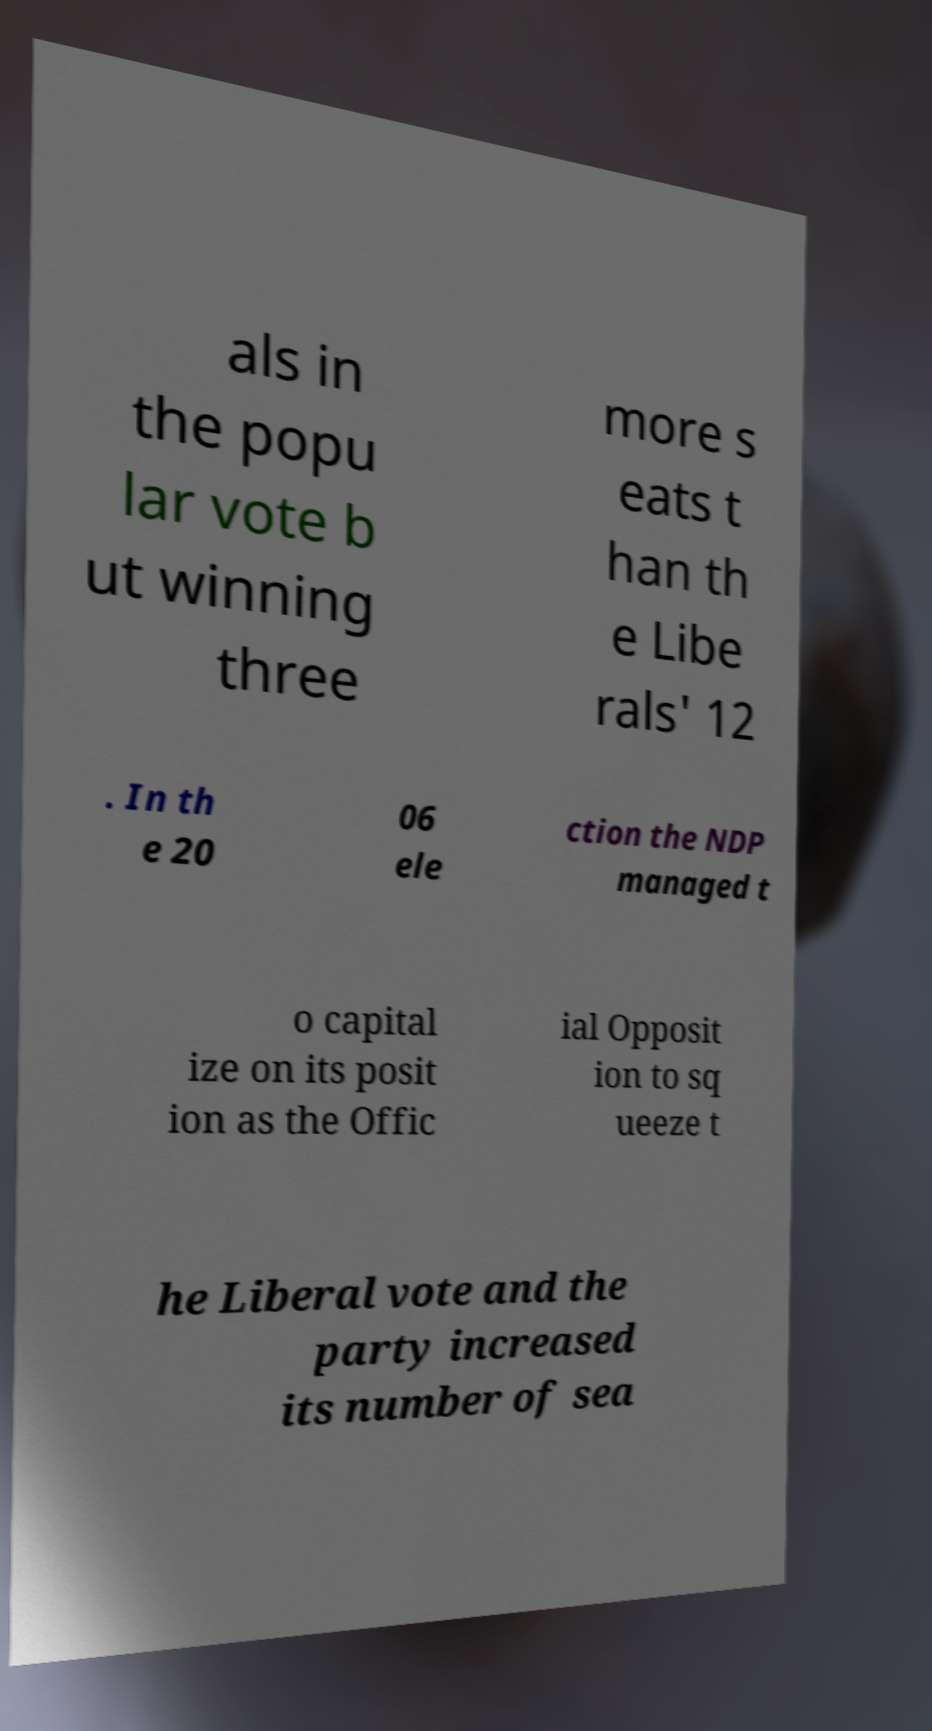Could you assist in decoding the text presented in this image and type it out clearly? als in the popu lar vote b ut winning three more s eats t han th e Libe rals' 12 . In th e 20 06 ele ction the NDP managed t o capital ize on its posit ion as the Offic ial Opposit ion to sq ueeze t he Liberal vote and the party increased its number of sea 